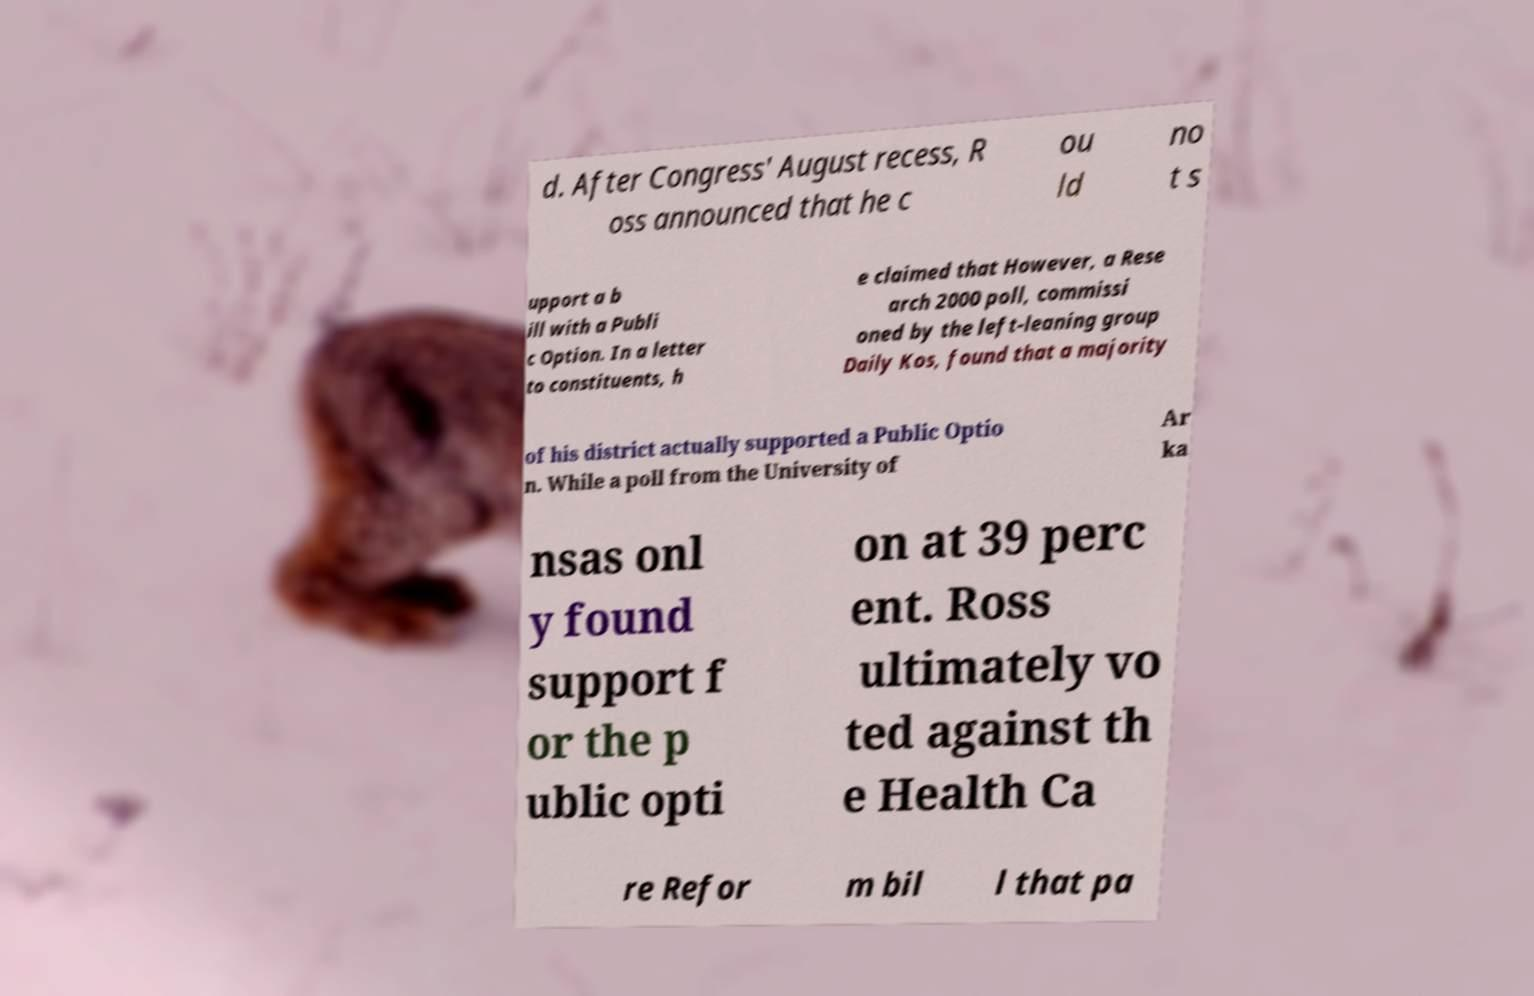Can you read and provide the text displayed in the image?This photo seems to have some interesting text. Can you extract and type it out for me? d. After Congress' August recess, R oss announced that he c ou ld no t s upport a b ill with a Publi c Option. In a letter to constituents, h e claimed that However, a Rese arch 2000 poll, commissi oned by the left-leaning group Daily Kos, found that a majority of his district actually supported a Public Optio n. While a poll from the University of Ar ka nsas onl y found support f or the p ublic opti on at 39 perc ent. Ross ultimately vo ted against th e Health Ca re Refor m bil l that pa 